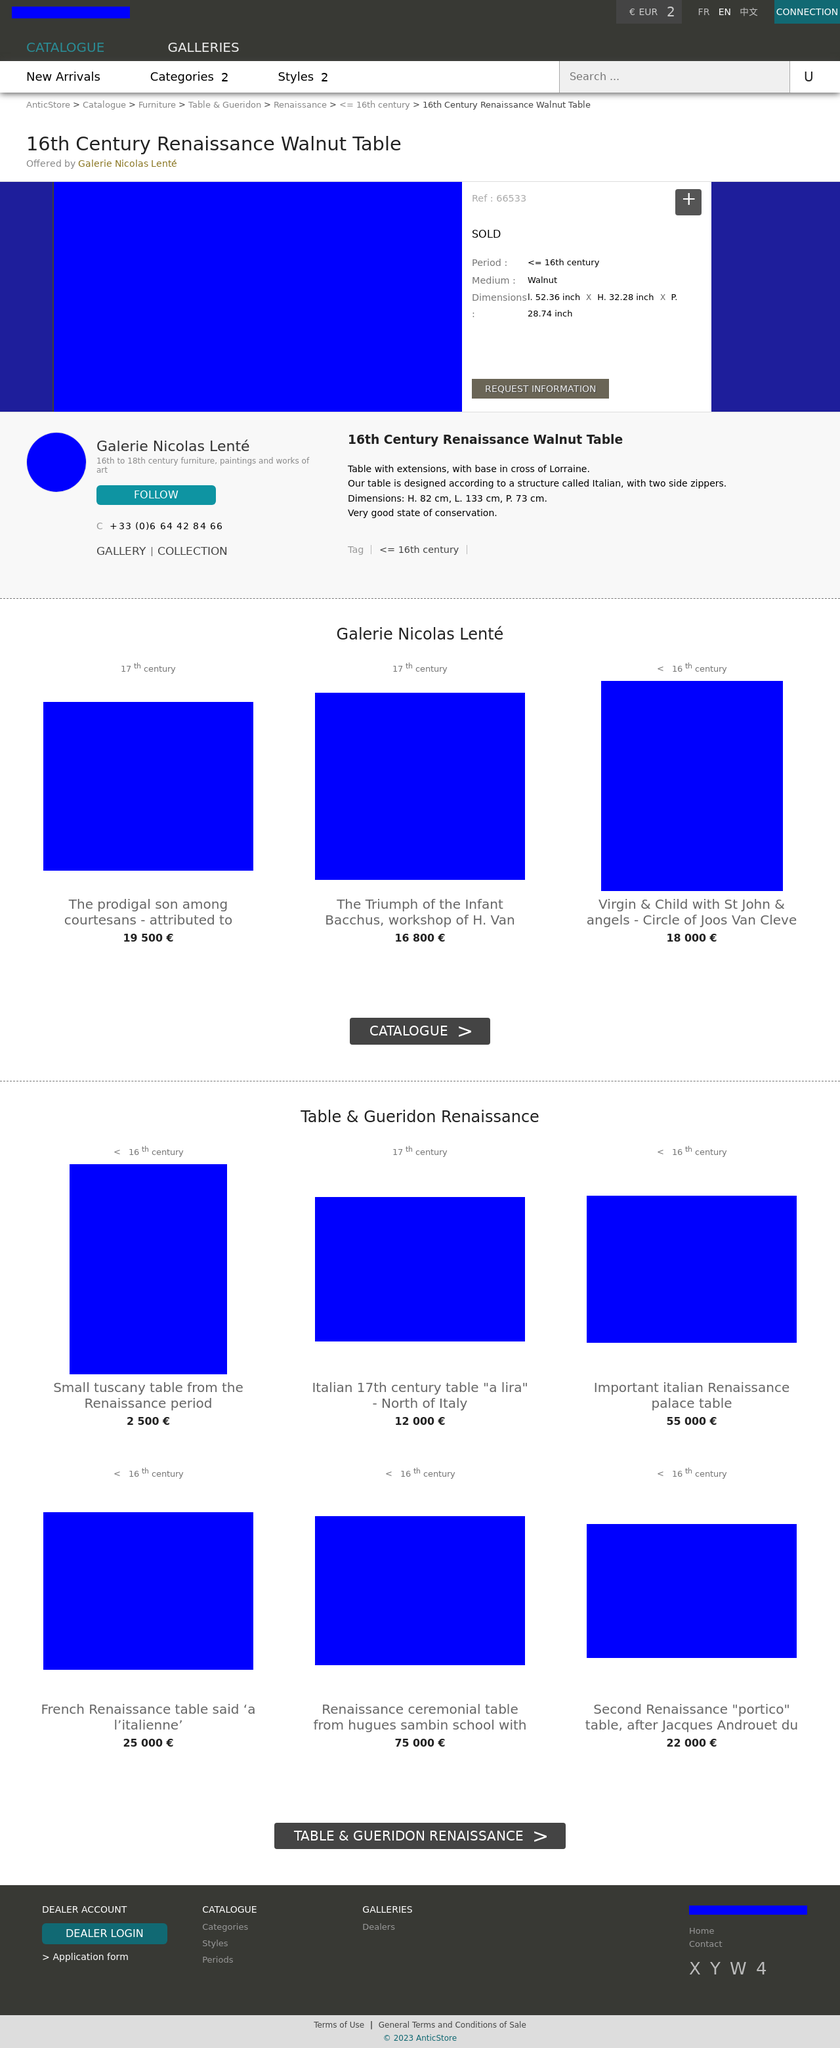I noticed the table is sold, but can you give me an idea of its value or importance? Such a 16th Century Renaissance Walnut Table would hold substantial value, not only monetarily but also historically. Its craftsmanship and period-specific design reflect the art and culture of the time, making it an important artifact. While the exact value of this particular table isn't listed since it's marked as sold, pieces like it can range significantly in price, often attracting high figures at auctions, depending on factors like provenance, condition, and historical importance. 